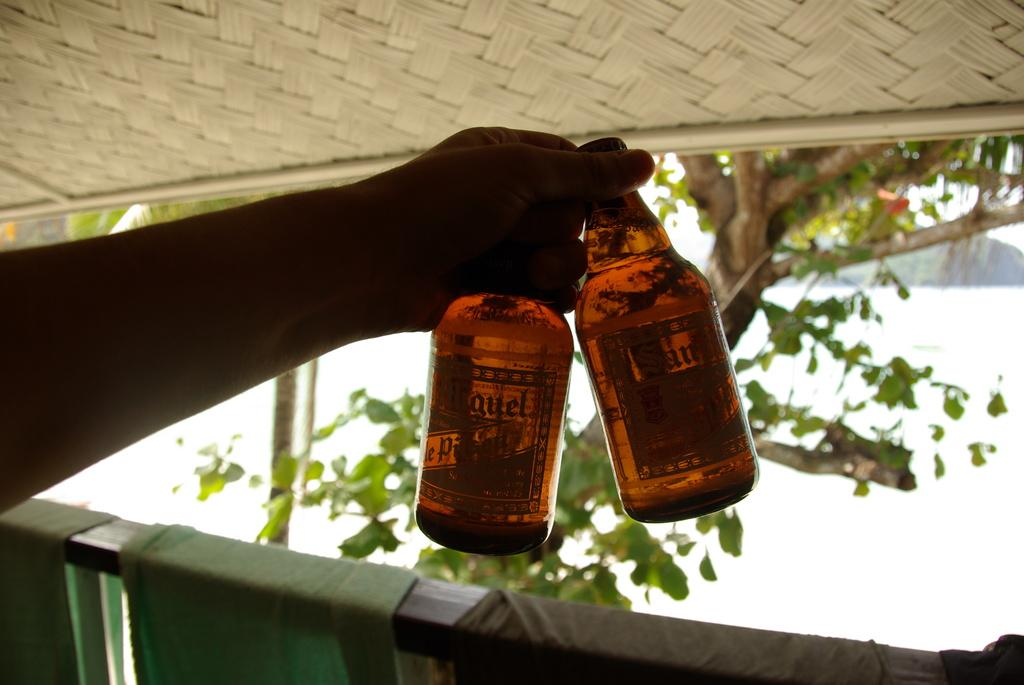What can be seen in the image related to a person's hand? There is a person's hand in the image. What is the hand holding? The hand is holding two bottles. Where are the hand and bottles located in the image? The hand and bottles are in the background of the image. What type of songs can be heard being sung by the person's friend in the image? There is no person's friend or singing present in the image; it only shows a person's hand holding two bottles. 